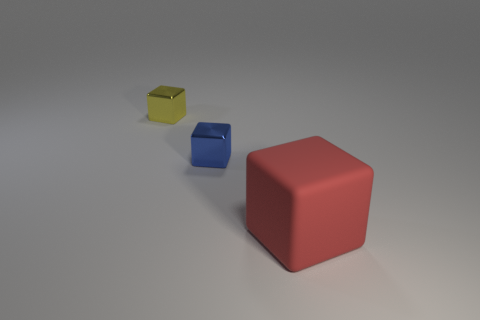Add 1 tiny blue blocks. How many objects exist? 4 Add 2 small yellow cubes. How many small yellow cubes exist? 3 Subtract 0 yellow cylinders. How many objects are left? 3 Subtract all small shiny objects. Subtract all big yellow rubber balls. How many objects are left? 1 Add 1 small blue metal objects. How many small blue metal objects are left? 2 